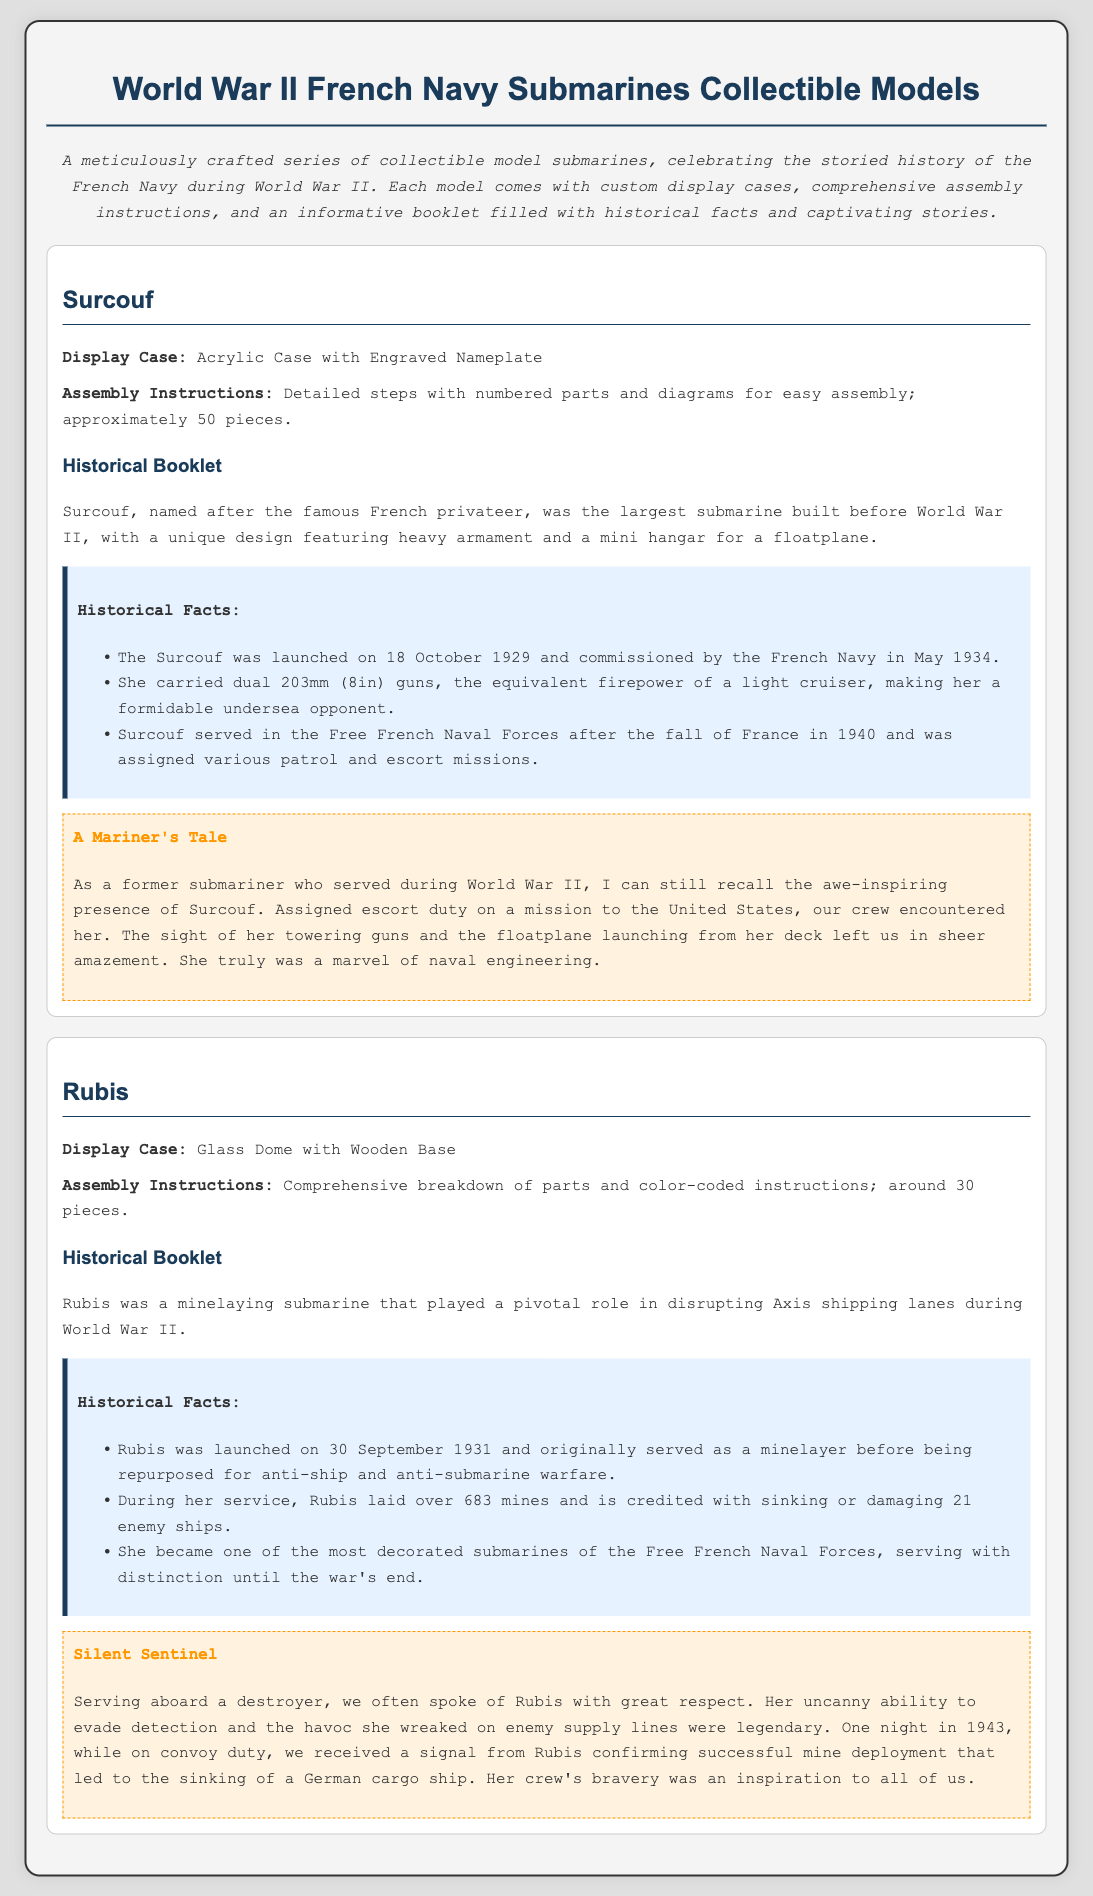what is the name of the first model submarine? The document lists the first model submarine as Surcouf.
Answer: Surcouf how many pieces does the Surcouf model have? The assembly instructions for the Surcouf specify approximately 50 pieces.
Answer: 50 pieces what type of display case does the Rubis submarine come with? The document states that Rubis comes with a Glass Dome with Wooden Base as its display case.
Answer: Glass Dome with Wooden Base when was the Rubis submarine launched? The launch date of the Rubis is indicated as 30 September 1931.
Answer: 30 September 1931 how many enemy ships is the Rubis credited with sinking or damaging? The historical facts about Rubis mention she is credited with sinking or damaging 21 enemy ships.
Answer: 21 what was the unique design feature of the Surcouf? The document describes a unique design feature of Surcouf as a mini hangar for a floatplane.
Answer: mini hangar for a floatplane who served with distinction until the war's end? The document states that Rubis became one of the most decorated submarines of the Free French Naval Forces, serving with distinction until the war's end.
Answer: Rubis which model had dual 203mm guns? It is mentioned in the document that the Surcouf had dual 203mm (8in) guns.
Answer: Surcouf what type of instructions does the Rubis model come with? The document indicates that Rubis comes with comprehensive breakdown of parts and color-coded instructions.
Answer: comprehensive breakdown of parts and color-coded instructions 